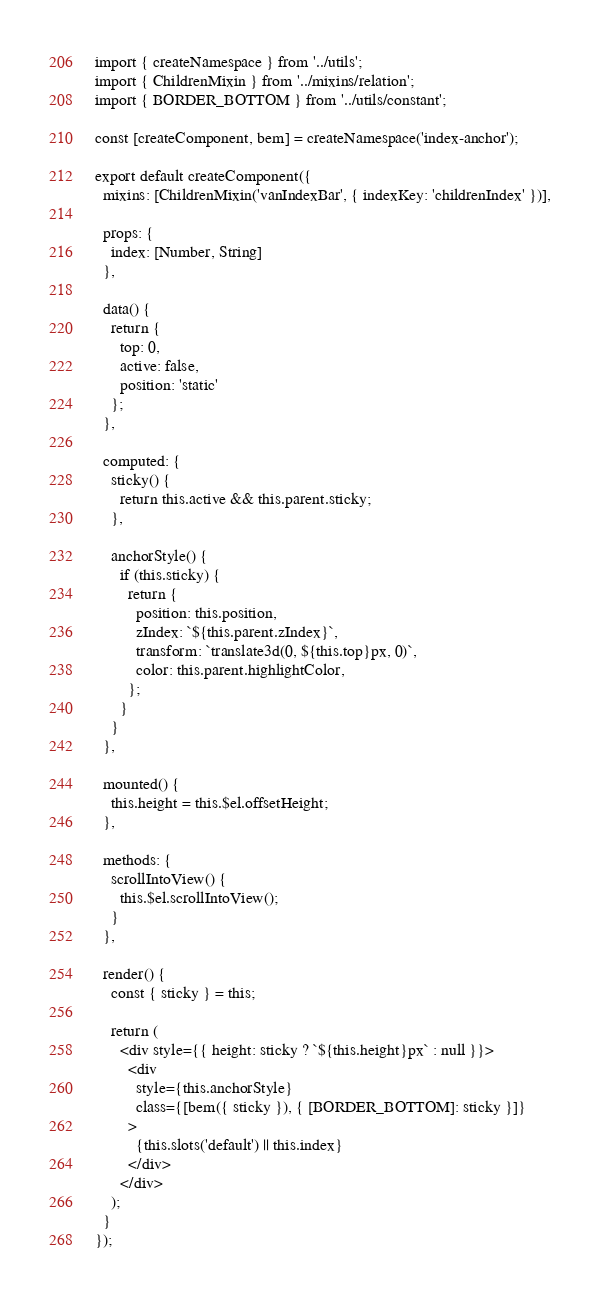<code> <loc_0><loc_0><loc_500><loc_500><_JavaScript_>import { createNamespace } from '../utils';
import { ChildrenMixin } from '../mixins/relation';
import { BORDER_BOTTOM } from '../utils/constant';

const [createComponent, bem] = createNamespace('index-anchor');

export default createComponent({
  mixins: [ChildrenMixin('vanIndexBar', { indexKey: 'childrenIndex' })],

  props: {
    index: [Number, String]
  },

  data() {
    return {
      top: 0,
      active: false,
      position: 'static'
    };
  },

  computed: {
    sticky() {
      return this.active && this.parent.sticky;
    },

    anchorStyle() {
      if (this.sticky) {
        return {
          position: this.position,
          zIndex: `${this.parent.zIndex}`,
          transform: `translate3d(0, ${this.top}px, 0)`,
          color: this.parent.highlightColor,
        };
      }
    }
  },

  mounted() {
    this.height = this.$el.offsetHeight;
  },

  methods: {
    scrollIntoView() {
      this.$el.scrollIntoView();
    }
  },

  render() {
    const { sticky } = this;

    return (
      <div style={{ height: sticky ? `${this.height}px` : null }}>
        <div
          style={this.anchorStyle}
          class={[bem({ sticky }), { [BORDER_BOTTOM]: sticky }]}
        >
          {this.slots('default') || this.index}
        </div>
      </div>
    );
  }
});
</code> 